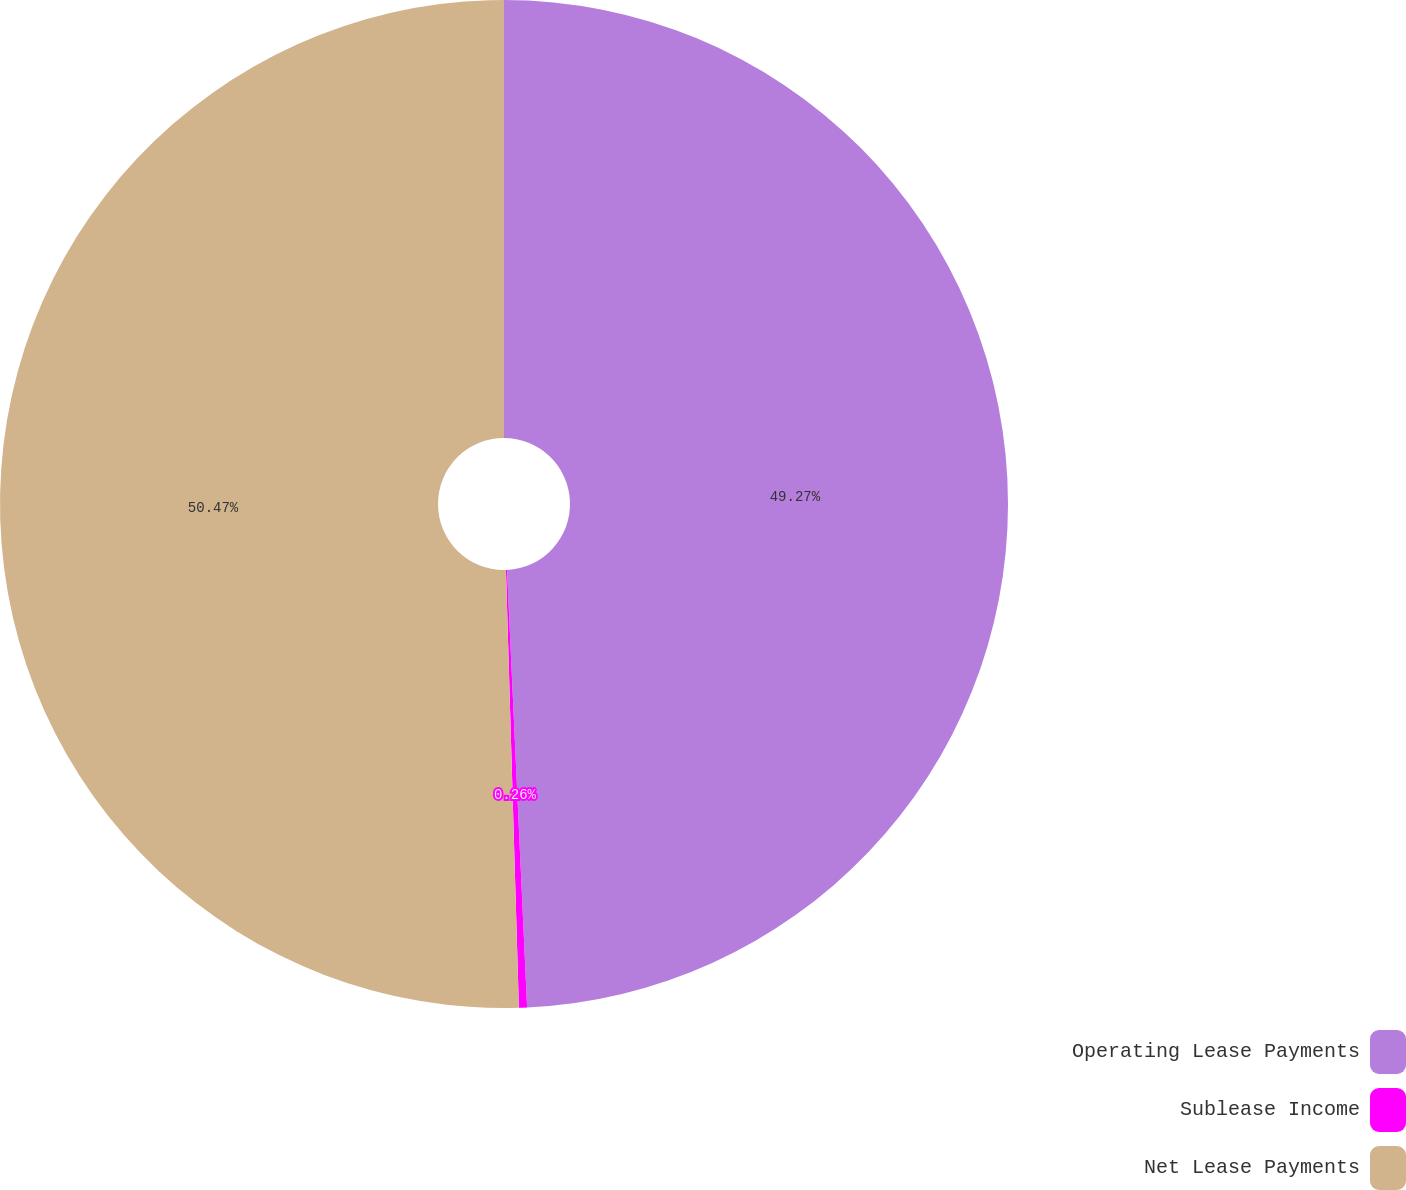<chart> <loc_0><loc_0><loc_500><loc_500><pie_chart><fcel>Operating Lease Payments<fcel>Sublease Income<fcel>Net Lease Payments<nl><fcel>49.27%<fcel>0.26%<fcel>50.47%<nl></chart> 